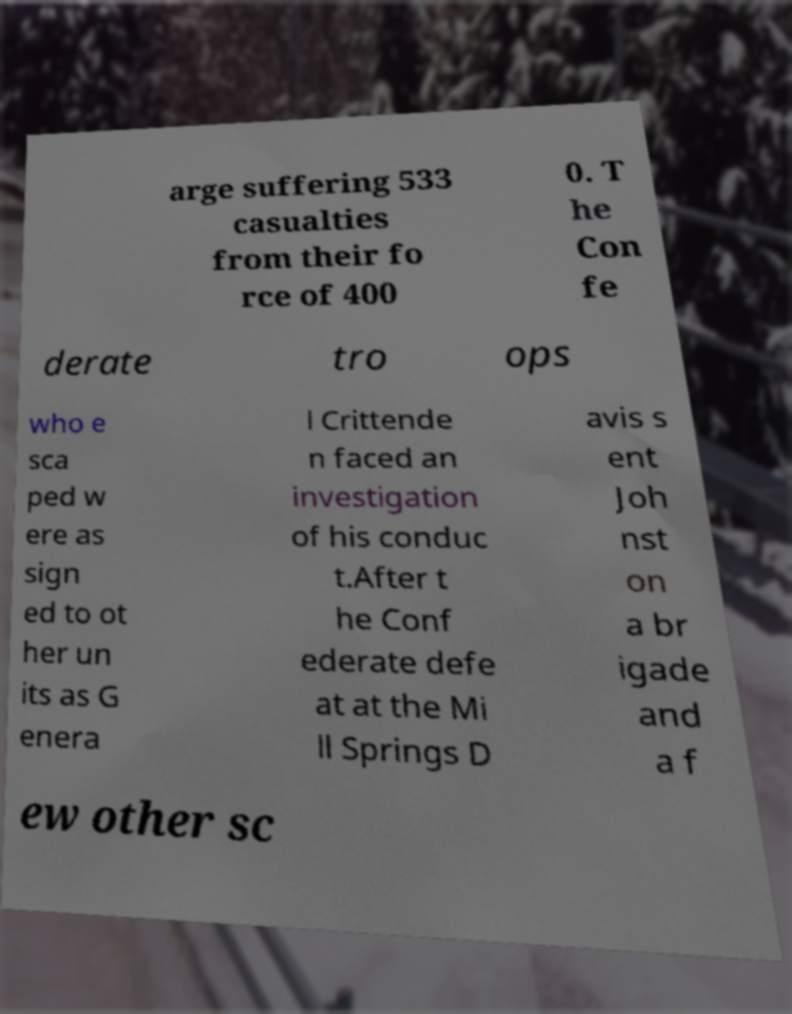What messages or text are displayed in this image? I need them in a readable, typed format. arge suffering 533 casualties from their fo rce of 400 0. T he Con fe derate tro ops who e sca ped w ere as sign ed to ot her un its as G enera l Crittende n faced an investigation of his conduc t.After t he Conf ederate defe at at the Mi ll Springs D avis s ent Joh nst on a br igade and a f ew other sc 